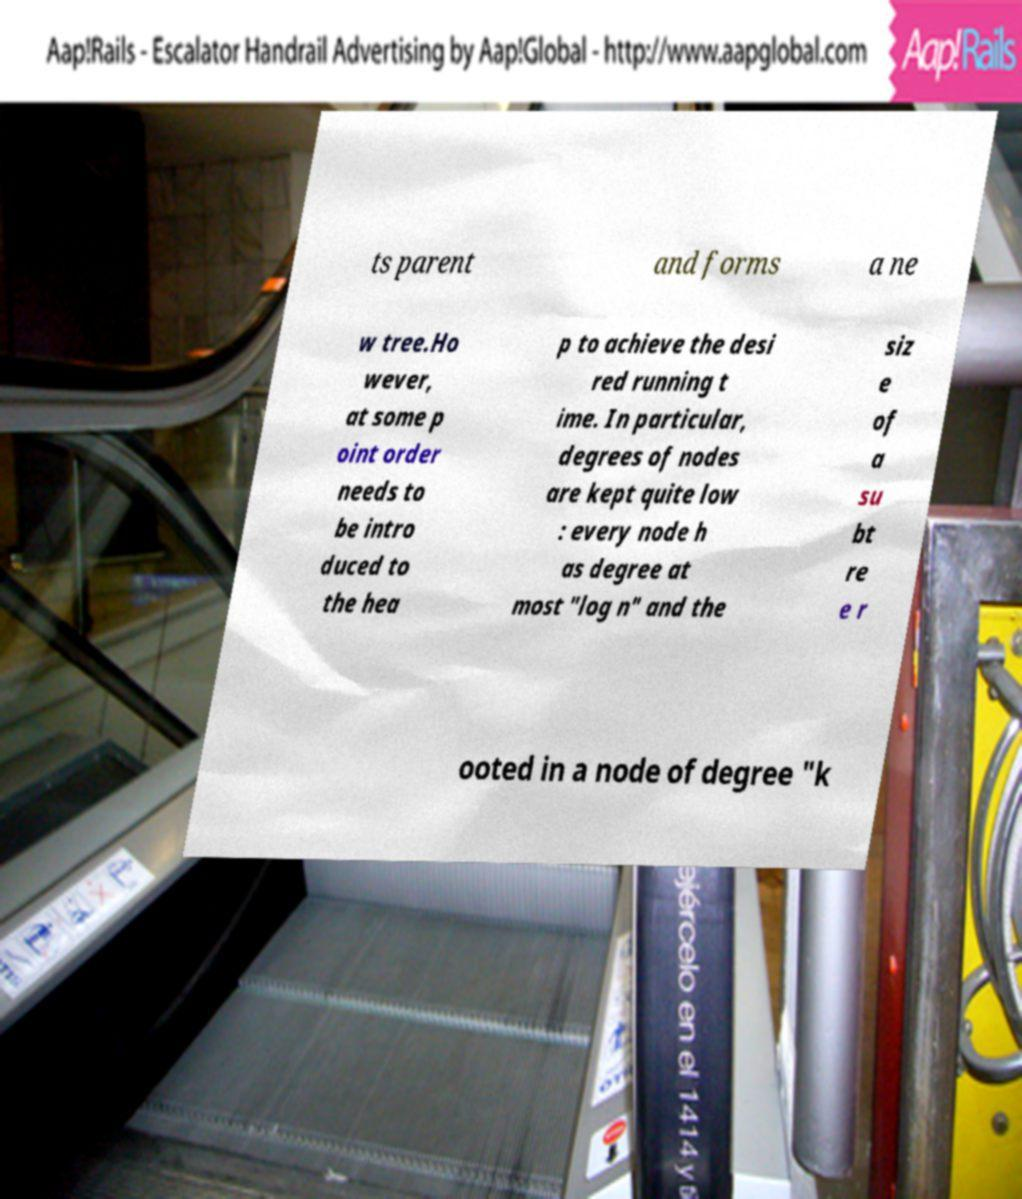Could you assist in decoding the text presented in this image and type it out clearly? ts parent and forms a ne w tree.Ho wever, at some p oint order needs to be intro duced to the hea p to achieve the desi red running t ime. In particular, degrees of nodes are kept quite low : every node h as degree at most "log n" and the siz e of a su bt re e r ooted in a node of degree "k 